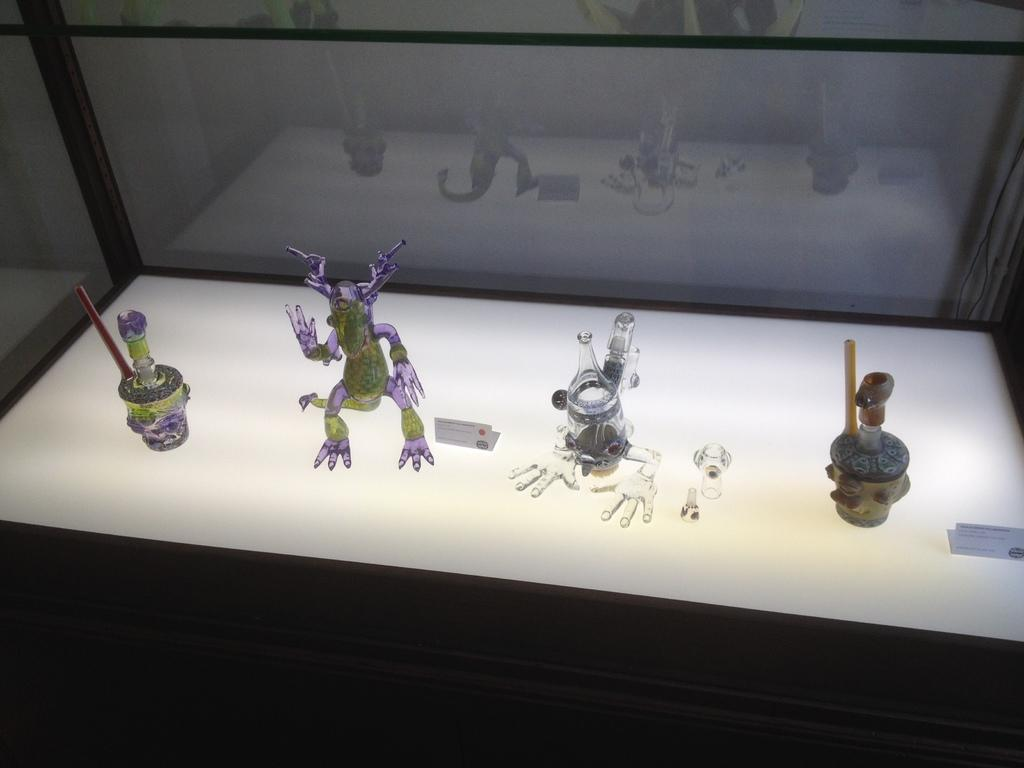What objects are present in the image? There are toys in the image. What is the color of the surface where the toys are placed? The surface where the toys are placed is white. What type of leather is used to make the circle in the image? There is no circle or leather present in the image; it only features toys on a white surface. 